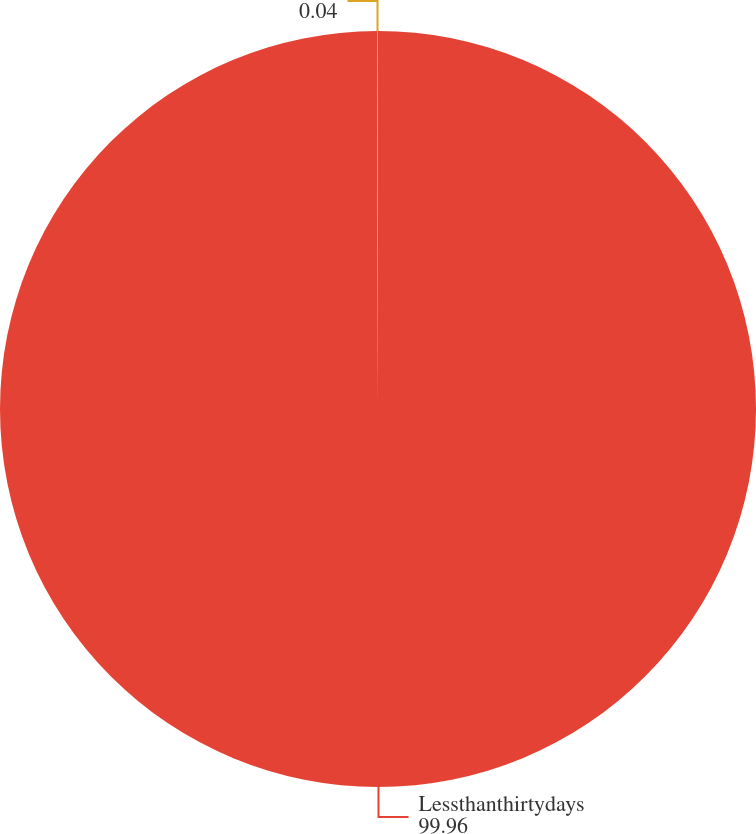Convert chart. <chart><loc_0><loc_0><loc_500><loc_500><pie_chart><fcel>Lessthanthirtydays<fcel>Unnamed: 1<nl><fcel>99.96%<fcel>0.04%<nl></chart> 